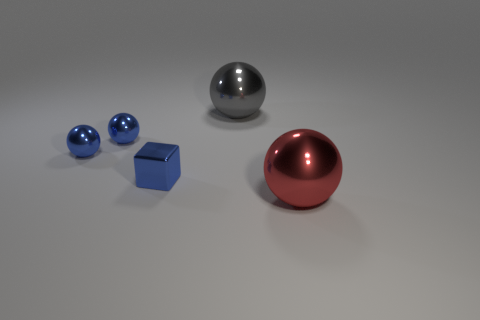Are there fewer shiny balls that are behind the red shiny sphere than tiny objects?
Your answer should be compact. No. Is there any other thing that is the same shape as the big gray shiny thing?
Provide a short and direct response. Yes. What color is the other big object that is the same shape as the red shiny thing?
Offer a terse response. Gray. There is a gray object that is behind the red ball; is its size the same as the red metal ball?
Provide a succinct answer. Yes. There is a object that is in front of the shiny cube that is left of the red metallic ball; what size is it?
Make the answer very short. Large. Are there fewer blue things that are to the right of the red sphere than large objects in front of the blue metal block?
Provide a short and direct response. Yes. There is a big thing that is made of the same material as the red ball; what is its color?
Your response must be concise. Gray. There is a metallic sphere in front of the small block; are there any blue metallic blocks behind it?
Make the answer very short. Yes. What is the color of the other metallic sphere that is the same size as the red shiny ball?
Keep it short and to the point. Gray. How many objects are tiny shiny balls or tiny purple cubes?
Offer a very short reply. 2. 